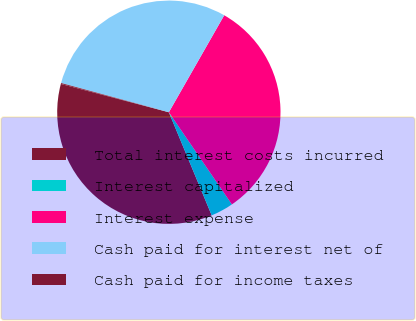Convert chart to OTSL. <chart><loc_0><loc_0><loc_500><loc_500><pie_chart><fcel>Total interest costs incurred<fcel>Interest capitalized<fcel>Interest expense<fcel>Cash paid for interest net of<fcel>Cash paid for income taxes<nl><fcel>35.34%<fcel>3.28%<fcel>32.19%<fcel>29.04%<fcel>0.13%<nl></chart> 